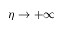Convert formula to latex. <formula><loc_0><loc_0><loc_500><loc_500>\eta \to + \infty</formula> 